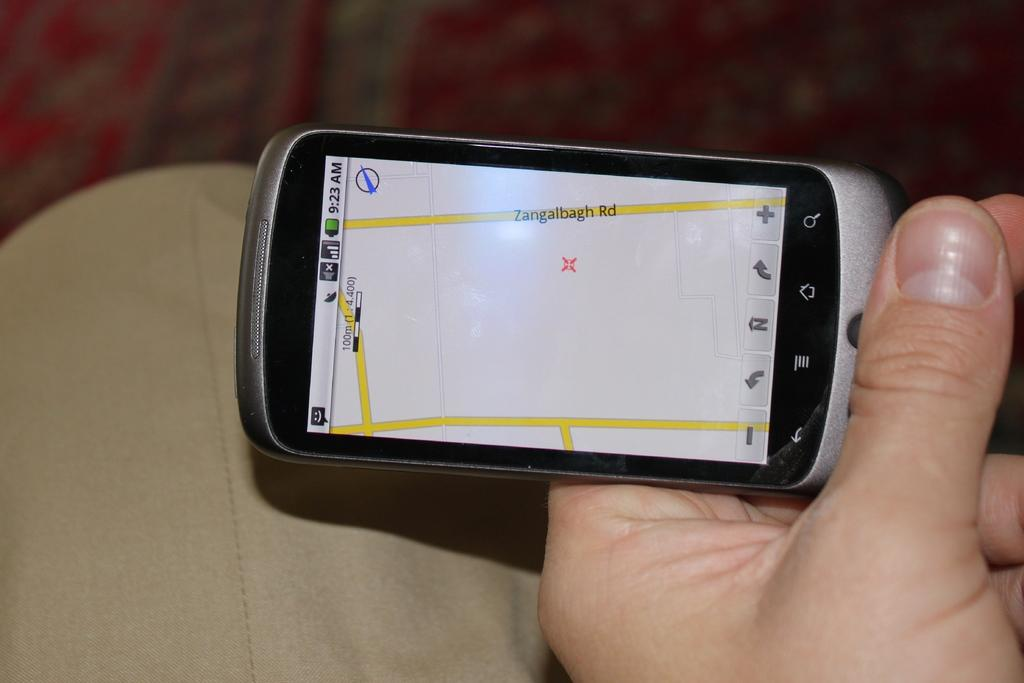<image>
Render a clear and concise summary of the photo. A person is looking at Zangalbagh Road on the map on their phone. 